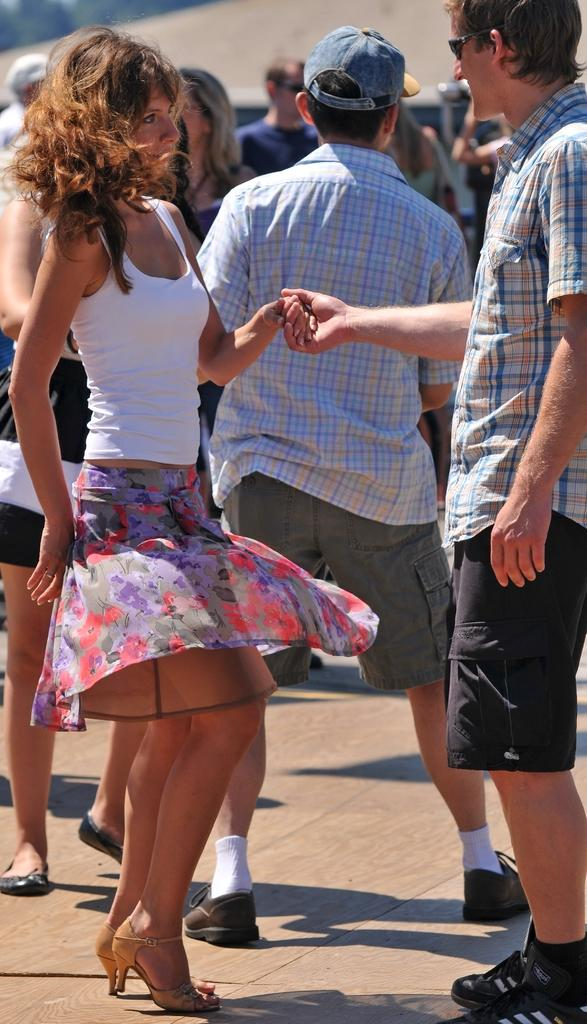How many people can be seen in the image? There are many people present in the image. Can you describe the positions of the woman and man in the picture? The woman and man are standing in the image. What is the gender of the two main subjects in the image? There is a woman and a man in the picture. What type of kettle is being used to establish a connection between the woman and man in the image? There is no kettle or connection between the woman and man in the image; they are simply standing together. Can you tell me the color of the sock worn by the man in the image? There is no sock visible on the man in the image. 